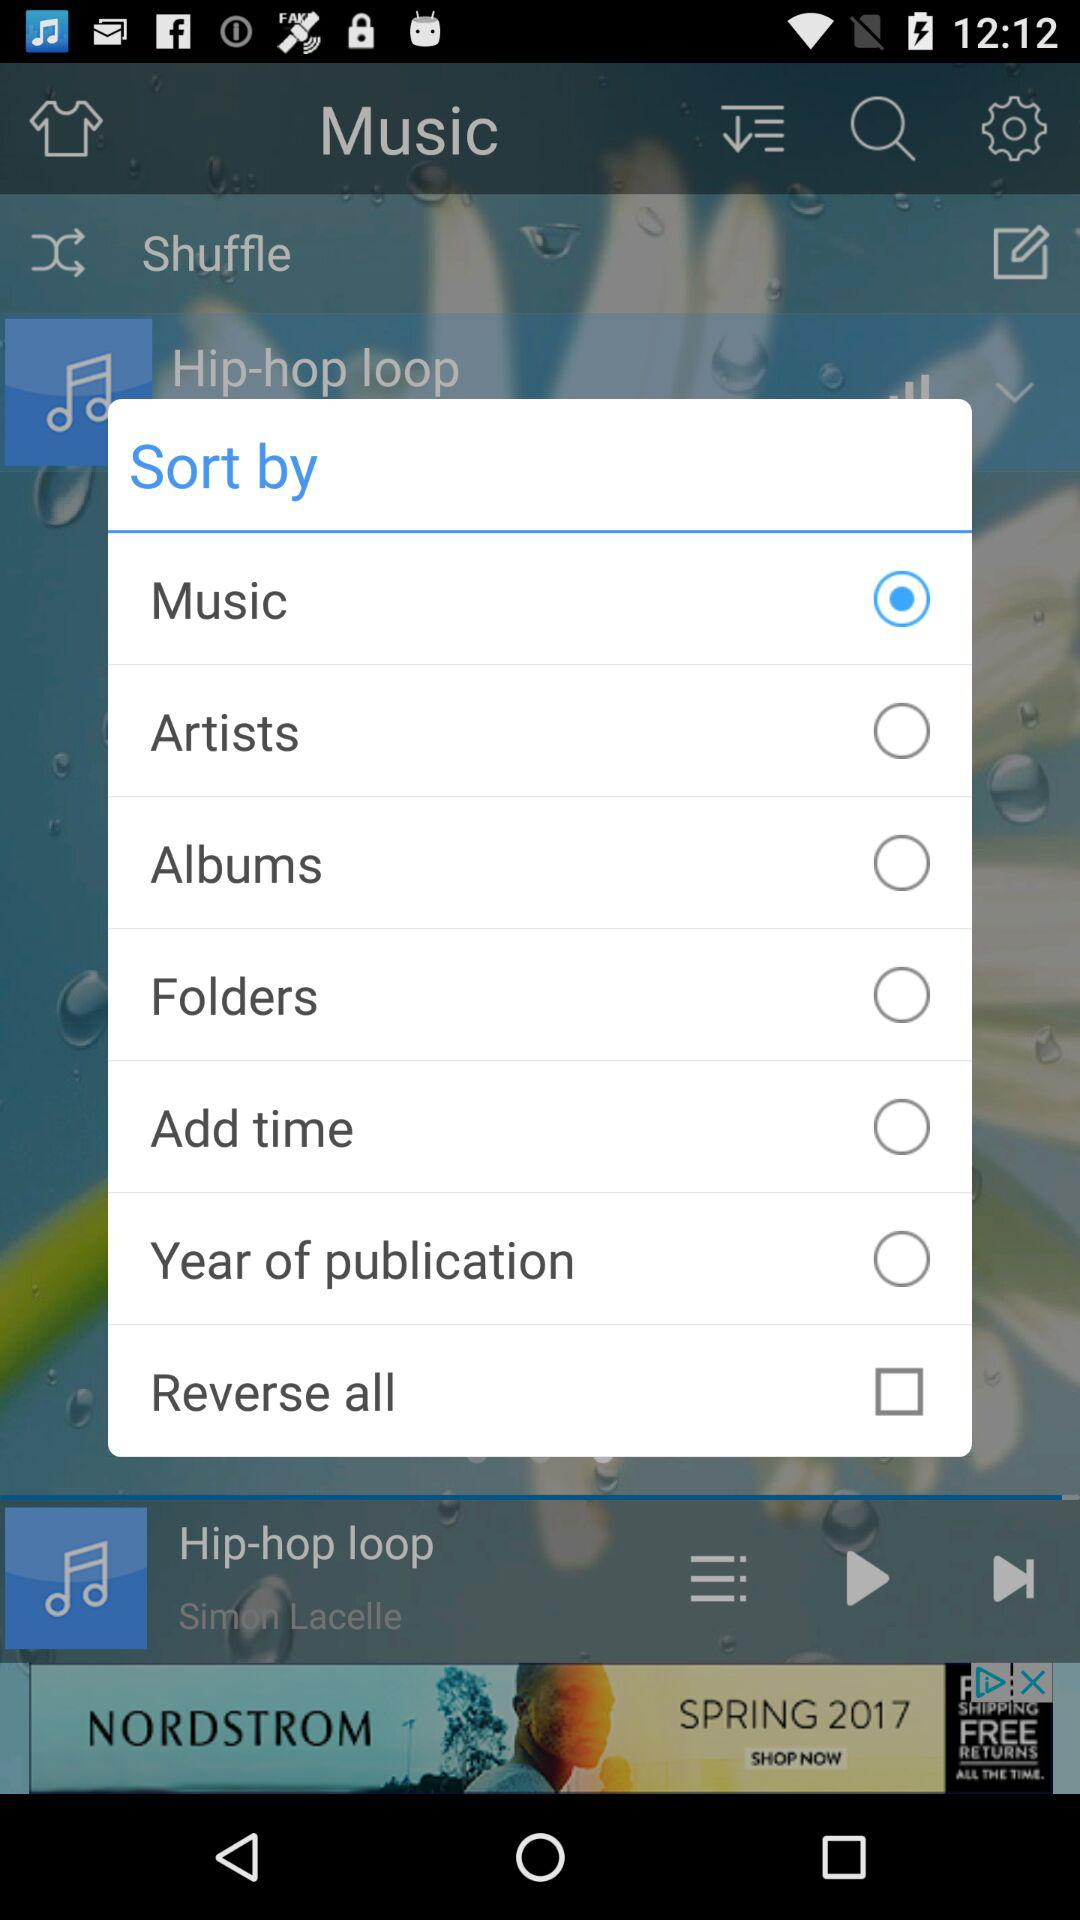How long is "Hip-hop loop"?
When the provided information is insufficient, respond with <no answer>. <no answer> 